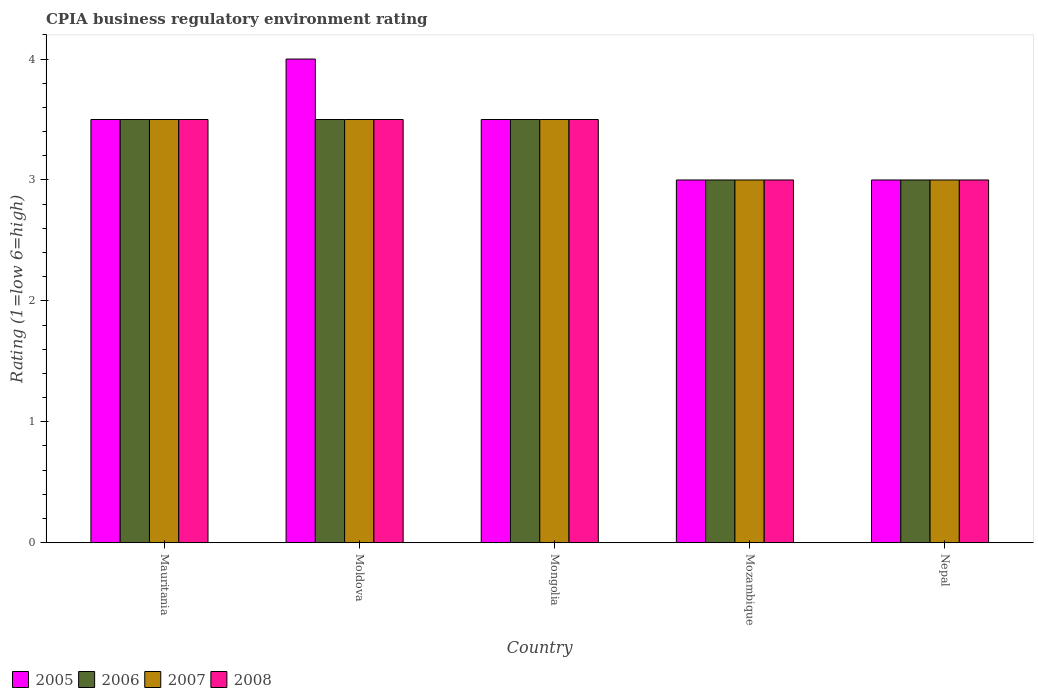How many different coloured bars are there?
Provide a short and direct response. 4. How many groups of bars are there?
Offer a terse response. 5. Are the number of bars per tick equal to the number of legend labels?
Give a very brief answer. Yes. Are the number of bars on each tick of the X-axis equal?
Offer a very short reply. Yes. How many bars are there on the 1st tick from the left?
Ensure brevity in your answer.  4. What is the label of the 2nd group of bars from the left?
Your answer should be very brief. Moldova. In how many cases, is the number of bars for a given country not equal to the number of legend labels?
Keep it short and to the point. 0. What is the CPIA rating in 2008 in Moldova?
Make the answer very short. 3.5. Across all countries, what is the minimum CPIA rating in 2005?
Your answer should be compact. 3. In which country was the CPIA rating in 2008 maximum?
Offer a very short reply. Mauritania. In which country was the CPIA rating in 2005 minimum?
Offer a terse response. Mozambique. What is the difference between the CPIA rating in 2006 in Moldova and the CPIA rating in 2008 in Mauritania?
Ensure brevity in your answer.  0. What is the ratio of the CPIA rating in 2006 in Mongolia to that in Nepal?
Make the answer very short. 1.17. Is the difference between the CPIA rating in 2005 in Mongolia and Mozambique greater than the difference between the CPIA rating in 2008 in Mongolia and Mozambique?
Your answer should be compact. No. What is the difference between the highest and the second highest CPIA rating in 2005?
Provide a succinct answer. -0.5. In how many countries, is the CPIA rating in 2008 greater than the average CPIA rating in 2008 taken over all countries?
Offer a very short reply. 3. Is it the case that in every country, the sum of the CPIA rating in 2005 and CPIA rating in 2006 is greater than the sum of CPIA rating in 2007 and CPIA rating in 2008?
Ensure brevity in your answer.  No. What does the 3rd bar from the left in Mauritania represents?
Offer a terse response. 2007. Is it the case that in every country, the sum of the CPIA rating in 2008 and CPIA rating in 2007 is greater than the CPIA rating in 2006?
Offer a very short reply. Yes. How many bars are there?
Your answer should be compact. 20. Are all the bars in the graph horizontal?
Make the answer very short. No. How are the legend labels stacked?
Give a very brief answer. Horizontal. What is the title of the graph?
Your response must be concise. CPIA business regulatory environment rating. Does "2006" appear as one of the legend labels in the graph?
Provide a succinct answer. Yes. What is the label or title of the Y-axis?
Provide a succinct answer. Rating (1=low 6=high). What is the Rating (1=low 6=high) in 2005 in Mauritania?
Keep it short and to the point. 3.5. What is the Rating (1=low 6=high) of 2007 in Mauritania?
Keep it short and to the point. 3.5. What is the Rating (1=low 6=high) in 2007 in Moldova?
Offer a terse response. 3.5. What is the Rating (1=low 6=high) of 2008 in Moldova?
Your answer should be very brief. 3.5. What is the Rating (1=low 6=high) in 2005 in Mongolia?
Provide a succinct answer. 3.5. What is the Rating (1=low 6=high) in 2006 in Mongolia?
Give a very brief answer. 3.5. What is the Rating (1=low 6=high) in 2007 in Mongolia?
Give a very brief answer. 3.5. What is the Rating (1=low 6=high) in 2005 in Mozambique?
Make the answer very short. 3. What is the Rating (1=low 6=high) in 2007 in Mozambique?
Provide a short and direct response. 3. What is the Rating (1=low 6=high) of 2005 in Nepal?
Your answer should be compact. 3. What is the Rating (1=low 6=high) in 2006 in Nepal?
Your answer should be compact. 3. What is the Rating (1=low 6=high) of 2008 in Nepal?
Offer a terse response. 3. Across all countries, what is the maximum Rating (1=low 6=high) in 2005?
Provide a short and direct response. 4. Across all countries, what is the maximum Rating (1=low 6=high) in 2006?
Make the answer very short. 3.5. Across all countries, what is the maximum Rating (1=low 6=high) in 2008?
Make the answer very short. 3.5. What is the total Rating (1=low 6=high) in 2006 in the graph?
Offer a very short reply. 16.5. What is the total Rating (1=low 6=high) of 2008 in the graph?
Your answer should be very brief. 16.5. What is the difference between the Rating (1=low 6=high) in 2005 in Mauritania and that in Moldova?
Your answer should be very brief. -0.5. What is the difference between the Rating (1=low 6=high) of 2006 in Mauritania and that in Moldova?
Offer a very short reply. 0. What is the difference between the Rating (1=low 6=high) in 2007 in Mauritania and that in Moldova?
Make the answer very short. 0. What is the difference between the Rating (1=low 6=high) in 2008 in Mauritania and that in Moldova?
Your response must be concise. 0. What is the difference between the Rating (1=low 6=high) in 2008 in Mauritania and that in Mongolia?
Provide a succinct answer. 0. What is the difference between the Rating (1=low 6=high) in 2005 in Mauritania and that in Mozambique?
Offer a terse response. 0.5. What is the difference between the Rating (1=low 6=high) in 2007 in Mauritania and that in Nepal?
Provide a succinct answer. 0.5. What is the difference between the Rating (1=low 6=high) in 2005 in Moldova and that in Mongolia?
Ensure brevity in your answer.  0.5. What is the difference between the Rating (1=low 6=high) in 2006 in Moldova and that in Mongolia?
Offer a terse response. 0. What is the difference between the Rating (1=low 6=high) in 2008 in Moldova and that in Mongolia?
Provide a succinct answer. 0. What is the difference between the Rating (1=low 6=high) in 2006 in Moldova and that in Mozambique?
Your answer should be compact. 0.5. What is the difference between the Rating (1=low 6=high) of 2007 in Moldova and that in Mozambique?
Your answer should be very brief. 0.5. What is the difference between the Rating (1=low 6=high) in 2006 in Moldova and that in Nepal?
Provide a succinct answer. 0.5. What is the difference between the Rating (1=low 6=high) in 2008 in Moldova and that in Nepal?
Make the answer very short. 0.5. What is the difference between the Rating (1=low 6=high) of 2005 in Mongolia and that in Mozambique?
Provide a short and direct response. 0.5. What is the difference between the Rating (1=low 6=high) in 2006 in Mongolia and that in Mozambique?
Give a very brief answer. 0.5. What is the difference between the Rating (1=low 6=high) of 2008 in Mongolia and that in Mozambique?
Give a very brief answer. 0.5. What is the difference between the Rating (1=low 6=high) in 2007 in Mongolia and that in Nepal?
Offer a terse response. 0.5. What is the difference between the Rating (1=low 6=high) of 2008 in Mongolia and that in Nepal?
Keep it short and to the point. 0.5. What is the difference between the Rating (1=low 6=high) in 2005 in Mozambique and that in Nepal?
Your response must be concise. 0. What is the difference between the Rating (1=low 6=high) of 2006 in Mozambique and that in Nepal?
Your response must be concise. 0. What is the difference between the Rating (1=low 6=high) in 2007 in Mozambique and that in Nepal?
Provide a short and direct response. 0. What is the difference between the Rating (1=low 6=high) in 2008 in Mozambique and that in Nepal?
Offer a terse response. 0. What is the difference between the Rating (1=low 6=high) in 2006 in Mauritania and the Rating (1=low 6=high) in 2008 in Moldova?
Offer a very short reply. 0. What is the difference between the Rating (1=low 6=high) of 2005 in Mauritania and the Rating (1=low 6=high) of 2007 in Mongolia?
Your answer should be compact. 0. What is the difference between the Rating (1=low 6=high) of 2005 in Mauritania and the Rating (1=low 6=high) of 2008 in Mongolia?
Your answer should be very brief. 0. What is the difference between the Rating (1=low 6=high) of 2006 in Mauritania and the Rating (1=low 6=high) of 2007 in Mongolia?
Offer a very short reply. 0. What is the difference between the Rating (1=low 6=high) in 2005 in Mauritania and the Rating (1=low 6=high) in 2006 in Mozambique?
Ensure brevity in your answer.  0.5. What is the difference between the Rating (1=low 6=high) in 2005 in Mauritania and the Rating (1=low 6=high) in 2007 in Mozambique?
Give a very brief answer. 0.5. What is the difference between the Rating (1=low 6=high) in 2005 in Mauritania and the Rating (1=low 6=high) in 2008 in Mozambique?
Your answer should be very brief. 0.5. What is the difference between the Rating (1=low 6=high) in 2005 in Mauritania and the Rating (1=low 6=high) in 2006 in Nepal?
Offer a very short reply. 0.5. What is the difference between the Rating (1=low 6=high) in 2005 in Mauritania and the Rating (1=low 6=high) in 2007 in Nepal?
Ensure brevity in your answer.  0.5. What is the difference between the Rating (1=low 6=high) of 2006 in Mauritania and the Rating (1=low 6=high) of 2008 in Nepal?
Your answer should be very brief. 0.5. What is the difference between the Rating (1=low 6=high) of 2007 in Mauritania and the Rating (1=low 6=high) of 2008 in Nepal?
Offer a terse response. 0.5. What is the difference between the Rating (1=low 6=high) of 2005 in Moldova and the Rating (1=low 6=high) of 2006 in Mongolia?
Make the answer very short. 0.5. What is the difference between the Rating (1=low 6=high) of 2005 in Moldova and the Rating (1=low 6=high) of 2007 in Mongolia?
Give a very brief answer. 0.5. What is the difference between the Rating (1=low 6=high) in 2005 in Moldova and the Rating (1=low 6=high) in 2008 in Mongolia?
Provide a short and direct response. 0.5. What is the difference between the Rating (1=low 6=high) of 2006 in Moldova and the Rating (1=low 6=high) of 2008 in Mongolia?
Keep it short and to the point. 0. What is the difference between the Rating (1=low 6=high) in 2005 in Moldova and the Rating (1=low 6=high) in 2006 in Mozambique?
Give a very brief answer. 1. What is the difference between the Rating (1=low 6=high) in 2005 in Moldova and the Rating (1=low 6=high) in 2008 in Mozambique?
Provide a succinct answer. 1. What is the difference between the Rating (1=low 6=high) of 2005 in Moldova and the Rating (1=low 6=high) of 2008 in Nepal?
Provide a short and direct response. 1. What is the difference between the Rating (1=low 6=high) in 2006 in Moldova and the Rating (1=low 6=high) in 2007 in Nepal?
Your answer should be compact. 0.5. What is the difference between the Rating (1=low 6=high) in 2006 in Moldova and the Rating (1=low 6=high) in 2008 in Nepal?
Keep it short and to the point. 0.5. What is the difference between the Rating (1=low 6=high) of 2007 in Moldova and the Rating (1=low 6=high) of 2008 in Nepal?
Provide a succinct answer. 0.5. What is the difference between the Rating (1=low 6=high) in 2005 in Mongolia and the Rating (1=low 6=high) in 2006 in Mozambique?
Your answer should be very brief. 0.5. What is the difference between the Rating (1=low 6=high) in 2005 in Mongolia and the Rating (1=low 6=high) in 2007 in Mozambique?
Ensure brevity in your answer.  0.5. What is the difference between the Rating (1=low 6=high) of 2006 in Mongolia and the Rating (1=low 6=high) of 2007 in Mozambique?
Your response must be concise. 0.5. What is the difference between the Rating (1=low 6=high) in 2007 in Mongolia and the Rating (1=low 6=high) in 2008 in Mozambique?
Your response must be concise. 0.5. What is the difference between the Rating (1=low 6=high) in 2005 in Mongolia and the Rating (1=low 6=high) in 2006 in Nepal?
Offer a very short reply. 0.5. What is the difference between the Rating (1=low 6=high) in 2005 in Mongolia and the Rating (1=low 6=high) in 2007 in Nepal?
Keep it short and to the point. 0.5. What is the difference between the Rating (1=low 6=high) of 2005 in Mongolia and the Rating (1=low 6=high) of 2008 in Nepal?
Keep it short and to the point. 0.5. What is the difference between the Rating (1=low 6=high) in 2006 in Mongolia and the Rating (1=low 6=high) in 2007 in Nepal?
Provide a succinct answer. 0.5. What is the difference between the Rating (1=low 6=high) of 2006 in Mongolia and the Rating (1=low 6=high) of 2008 in Nepal?
Give a very brief answer. 0.5. What is the difference between the Rating (1=low 6=high) in 2007 in Mongolia and the Rating (1=low 6=high) in 2008 in Nepal?
Offer a very short reply. 0.5. What is the difference between the Rating (1=low 6=high) in 2005 in Mozambique and the Rating (1=low 6=high) in 2006 in Nepal?
Keep it short and to the point. 0. What is the difference between the Rating (1=low 6=high) of 2005 in Mozambique and the Rating (1=low 6=high) of 2007 in Nepal?
Make the answer very short. 0. What is the difference between the Rating (1=low 6=high) of 2006 in Mozambique and the Rating (1=low 6=high) of 2007 in Nepal?
Give a very brief answer. 0. What is the difference between the Rating (1=low 6=high) in 2006 in Mozambique and the Rating (1=low 6=high) in 2008 in Nepal?
Give a very brief answer. 0. What is the average Rating (1=low 6=high) of 2005 per country?
Your answer should be very brief. 3.4. What is the average Rating (1=low 6=high) in 2007 per country?
Give a very brief answer. 3.3. What is the average Rating (1=low 6=high) of 2008 per country?
Your answer should be very brief. 3.3. What is the difference between the Rating (1=low 6=high) in 2006 and Rating (1=low 6=high) in 2007 in Mauritania?
Your response must be concise. 0. What is the difference between the Rating (1=low 6=high) of 2007 and Rating (1=low 6=high) of 2008 in Mauritania?
Offer a terse response. 0. What is the difference between the Rating (1=low 6=high) in 2005 and Rating (1=low 6=high) in 2008 in Moldova?
Make the answer very short. 0.5. What is the difference between the Rating (1=low 6=high) of 2006 and Rating (1=low 6=high) of 2007 in Moldova?
Provide a short and direct response. 0. What is the difference between the Rating (1=low 6=high) in 2007 and Rating (1=low 6=high) in 2008 in Moldova?
Provide a succinct answer. 0. What is the difference between the Rating (1=low 6=high) in 2005 and Rating (1=low 6=high) in 2007 in Mongolia?
Make the answer very short. 0. What is the difference between the Rating (1=low 6=high) in 2005 and Rating (1=low 6=high) in 2008 in Mongolia?
Provide a succinct answer. 0. What is the difference between the Rating (1=low 6=high) of 2006 and Rating (1=low 6=high) of 2007 in Mongolia?
Provide a short and direct response. 0. What is the difference between the Rating (1=low 6=high) of 2007 and Rating (1=low 6=high) of 2008 in Mongolia?
Make the answer very short. 0. What is the difference between the Rating (1=low 6=high) of 2006 and Rating (1=low 6=high) of 2008 in Mozambique?
Offer a very short reply. 0. What is the difference between the Rating (1=low 6=high) in 2005 and Rating (1=low 6=high) in 2006 in Nepal?
Offer a terse response. 0. What is the difference between the Rating (1=low 6=high) of 2006 and Rating (1=low 6=high) of 2007 in Nepal?
Offer a very short reply. 0. What is the ratio of the Rating (1=low 6=high) of 2007 in Mauritania to that in Moldova?
Your response must be concise. 1. What is the ratio of the Rating (1=low 6=high) in 2007 in Mauritania to that in Mongolia?
Provide a short and direct response. 1. What is the ratio of the Rating (1=low 6=high) in 2008 in Mauritania to that in Mongolia?
Your response must be concise. 1. What is the ratio of the Rating (1=low 6=high) of 2005 in Mauritania to that in Mozambique?
Offer a terse response. 1.17. What is the ratio of the Rating (1=low 6=high) in 2008 in Mauritania to that in Mozambique?
Offer a very short reply. 1.17. What is the ratio of the Rating (1=low 6=high) in 2005 in Mauritania to that in Nepal?
Ensure brevity in your answer.  1.17. What is the ratio of the Rating (1=low 6=high) of 2006 in Mauritania to that in Nepal?
Your answer should be compact. 1.17. What is the ratio of the Rating (1=low 6=high) of 2007 in Mauritania to that in Nepal?
Your answer should be very brief. 1.17. What is the ratio of the Rating (1=low 6=high) in 2008 in Mauritania to that in Nepal?
Keep it short and to the point. 1.17. What is the ratio of the Rating (1=low 6=high) in 2008 in Moldova to that in Mongolia?
Your answer should be very brief. 1. What is the ratio of the Rating (1=low 6=high) in 2007 in Moldova to that in Mozambique?
Provide a succinct answer. 1.17. What is the ratio of the Rating (1=low 6=high) of 2006 in Moldova to that in Nepal?
Your answer should be compact. 1.17. What is the ratio of the Rating (1=low 6=high) of 2007 in Moldova to that in Nepal?
Keep it short and to the point. 1.17. What is the ratio of the Rating (1=low 6=high) in 2008 in Moldova to that in Nepal?
Make the answer very short. 1.17. What is the ratio of the Rating (1=low 6=high) in 2005 in Mongolia to that in Nepal?
Provide a short and direct response. 1.17. What is the ratio of the Rating (1=low 6=high) of 2006 in Mongolia to that in Nepal?
Your answer should be compact. 1.17. What is the ratio of the Rating (1=low 6=high) of 2007 in Mongolia to that in Nepal?
Your answer should be very brief. 1.17. What is the ratio of the Rating (1=low 6=high) of 2005 in Mozambique to that in Nepal?
Provide a short and direct response. 1. What is the ratio of the Rating (1=low 6=high) in 2006 in Mozambique to that in Nepal?
Your response must be concise. 1. What is the ratio of the Rating (1=low 6=high) in 2007 in Mozambique to that in Nepal?
Your answer should be compact. 1. What is the ratio of the Rating (1=low 6=high) in 2008 in Mozambique to that in Nepal?
Your response must be concise. 1. What is the difference between the highest and the second highest Rating (1=low 6=high) of 2005?
Provide a short and direct response. 0.5. What is the difference between the highest and the second highest Rating (1=low 6=high) of 2006?
Provide a short and direct response. 0. What is the difference between the highest and the second highest Rating (1=low 6=high) of 2007?
Give a very brief answer. 0. What is the difference between the highest and the lowest Rating (1=low 6=high) in 2005?
Provide a succinct answer. 1. What is the difference between the highest and the lowest Rating (1=low 6=high) of 2006?
Provide a succinct answer. 0.5. What is the difference between the highest and the lowest Rating (1=low 6=high) of 2007?
Provide a succinct answer. 0.5. What is the difference between the highest and the lowest Rating (1=low 6=high) of 2008?
Provide a short and direct response. 0.5. 